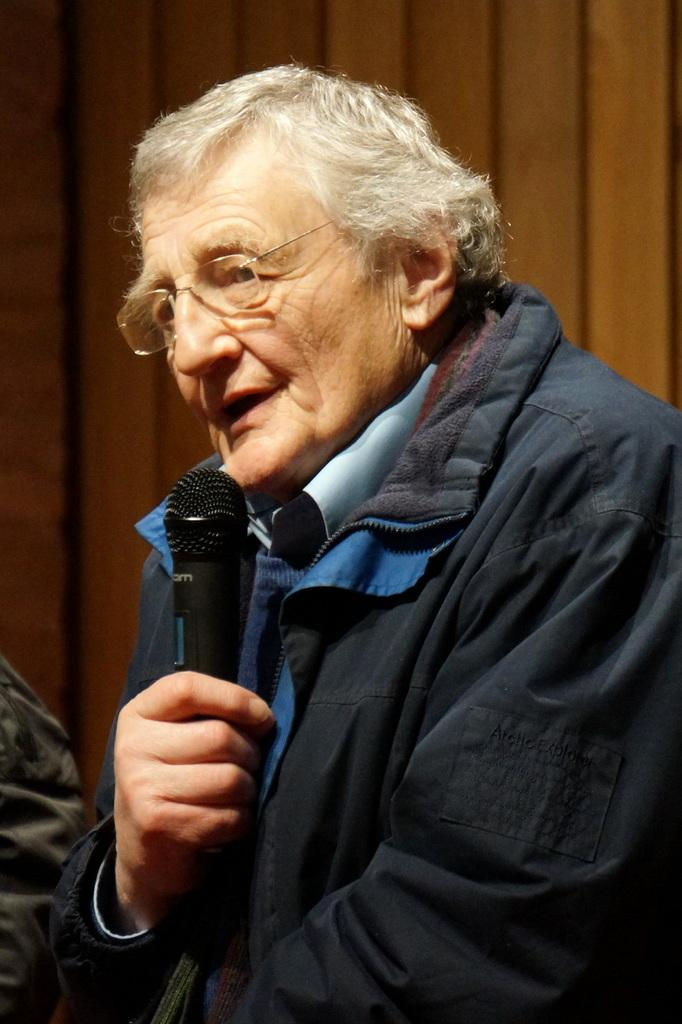What is the main subject of the picture? The main subject of the picture is an old person. What is the old person doing in the picture? The old person is speaking in the picture. How is the old person communicating their speech? The old person is holding a microphone in their right hand. What is the taste of the ant in the picture? There is no ant present in the picture, so it is not possible to determine its taste. 